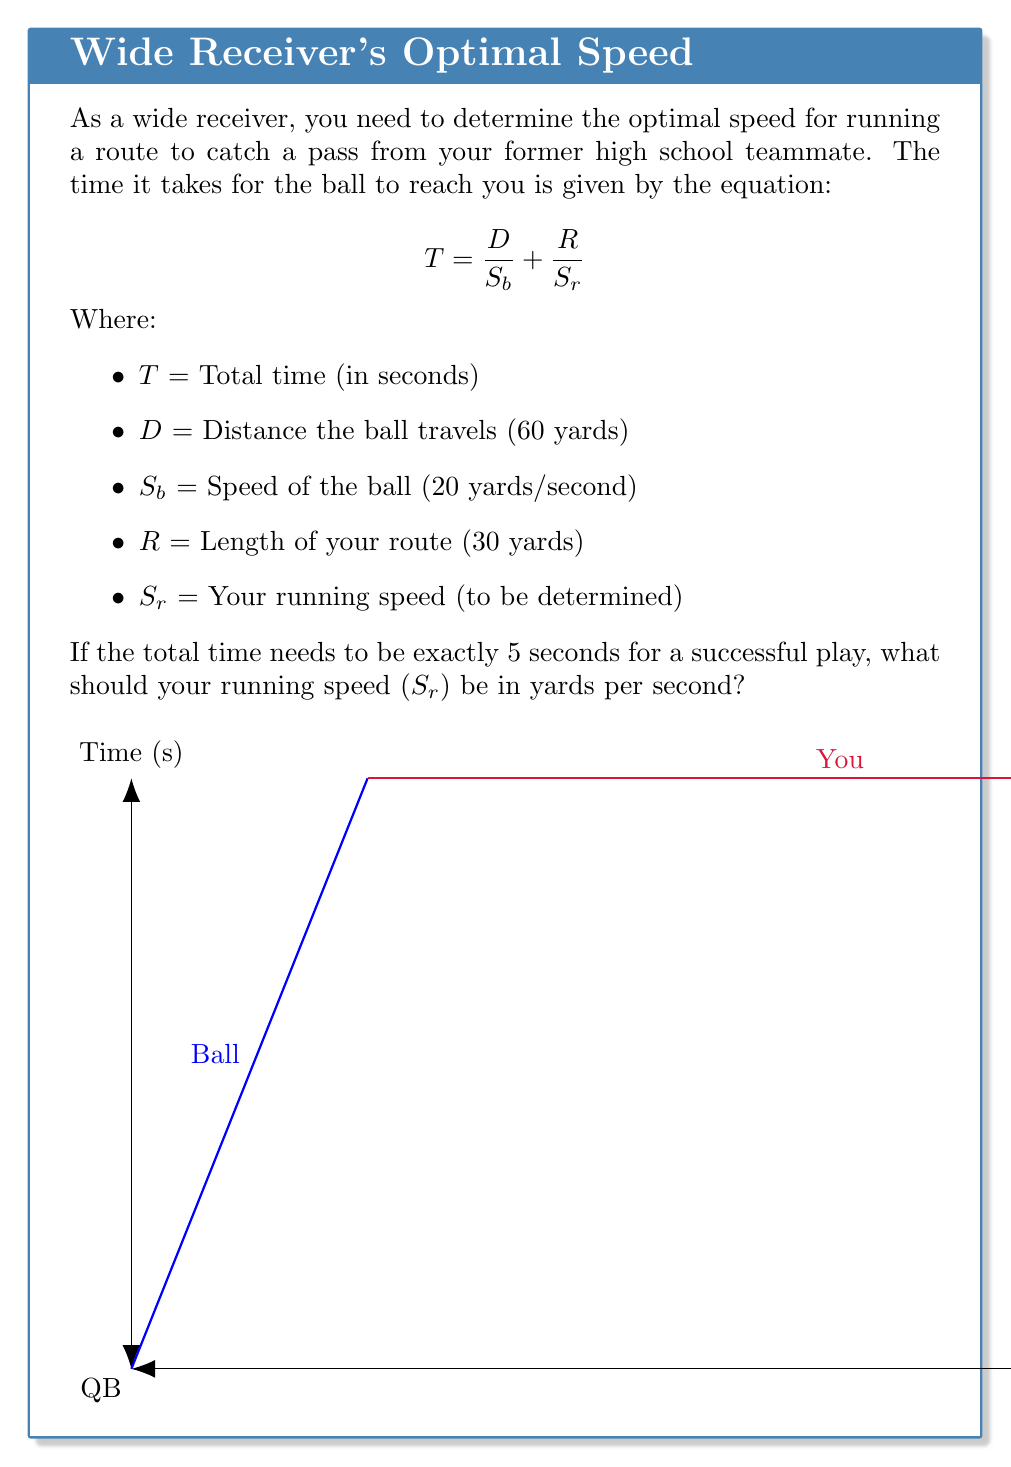Could you help me with this problem? Let's solve this step-by-step:

1) We start with the given equation:
   $$T = \frac{D}{S_b} + \frac{R}{S_r}$$

2) We know the following values:
   $T = 5$ seconds
   $D = 60$ yards
   $S_b = 20$ yards/second
   $R = 30$ yards

3) Let's substitute these values into the equation:
   $$5 = \frac{60}{20} + \frac{30}{S_r}$$

4) Simplify the first fraction:
   $$5 = 3 + \frac{30}{S_r}$$

5) Subtract 3 from both sides:
   $$2 = \frac{30}{S_r}$$

6) Multiply both sides by $S_r$:
   $$2S_r = 30$$

7) Divide both sides by 2:
   $$S_r = 15$$

Therefore, your running speed should be 15 yards per second for the play to take exactly 5 seconds.
Answer: $S_r = 15$ yards/second 